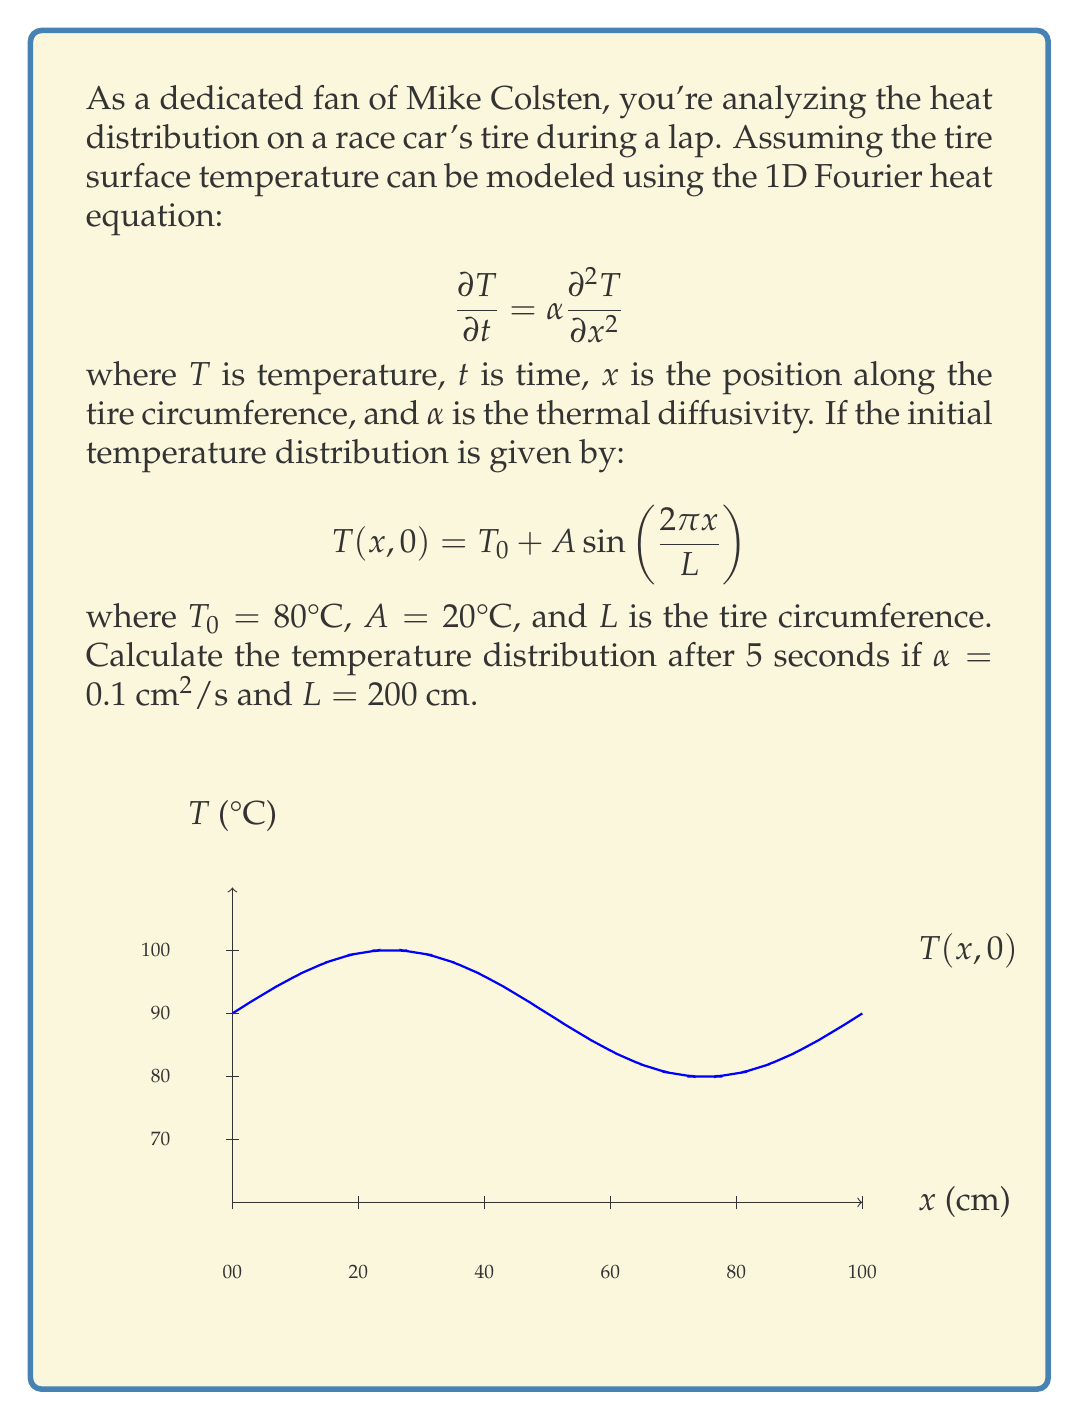Help me with this question. To solve this problem, we'll use the separation of variables method for the Fourier heat equation:

1) The general solution for the 1D Fourier heat equation is:

   $$T(x,t) = T_0 + \sum_{n=1}^{\infty} B_n e^{-\alpha k_n^2 t} \sin(k_n x)$$

   where $k_n = \frac{2\pi n}{L}$

2) Our initial condition matches this form with $n=1$:

   $$T(x,0) = T_0 + A \sin(\frac{2\pi x}{L})$$

3) Therefore, $B_1 = A = 20°C$ and $k_1 = \frac{2\pi}{L} = \frac{2\pi}{200} = \frac{\pi}{100}$

4) The temperature distribution after time $t$ is:

   $$T(x,t) = T_0 + A e^{-\alpha k_1^2 t} \sin(\frac{2\pi x}{L})$$

5) Substituting the values:

   $$T(x,5) = 80 + 20 e^{-0.1 (\frac{\pi}{100})^2 5} \sin(\frac{2\pi x}{200})$$

6) Simplify the exponent:

   $$e^{-0.1 (\frac{\pi}{100})^2 5} \approx e^{-0.000493} \approx 0.9995$$

7) The final temperature distribution is:

   $$T(x,5) \approx 80 + 19.99 \sin(\frac{\pi x}{100})$$
Answer: $T(x,5) \approx 80 + 19.99 \sin(\frac{\pi x}{100})$ °C 